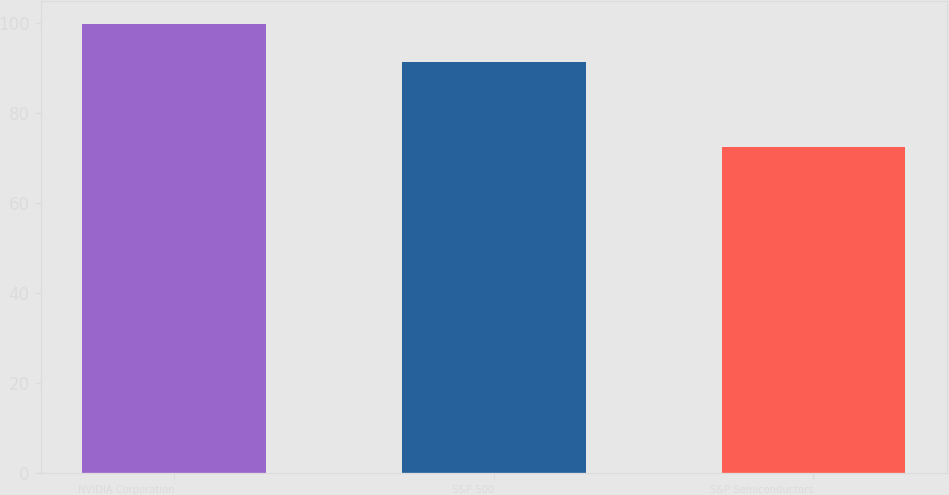<chart> <loc_0><loc_0><loc_500><loc_500><bar_chart><fcel>NVIDIA Corporation<fcel>S&P 500<fcel>S&P Semiconductors<nl><fcel>99.83<fcel>91.41<fcel>72.37<nl></chart> 